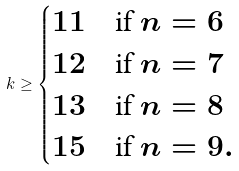Convert formula to latex. <formula><loc_0><loc_0><loc_500><loc_500>k \geq \begin{cases} 1 1 & \text {if } n = 6 \\ 1 2 & \text {if } n = 7 \\ 1 3 & \text {if } n = 8 \\ 1 5 & \text {if } n = 9 . \end{cases}</formula> 